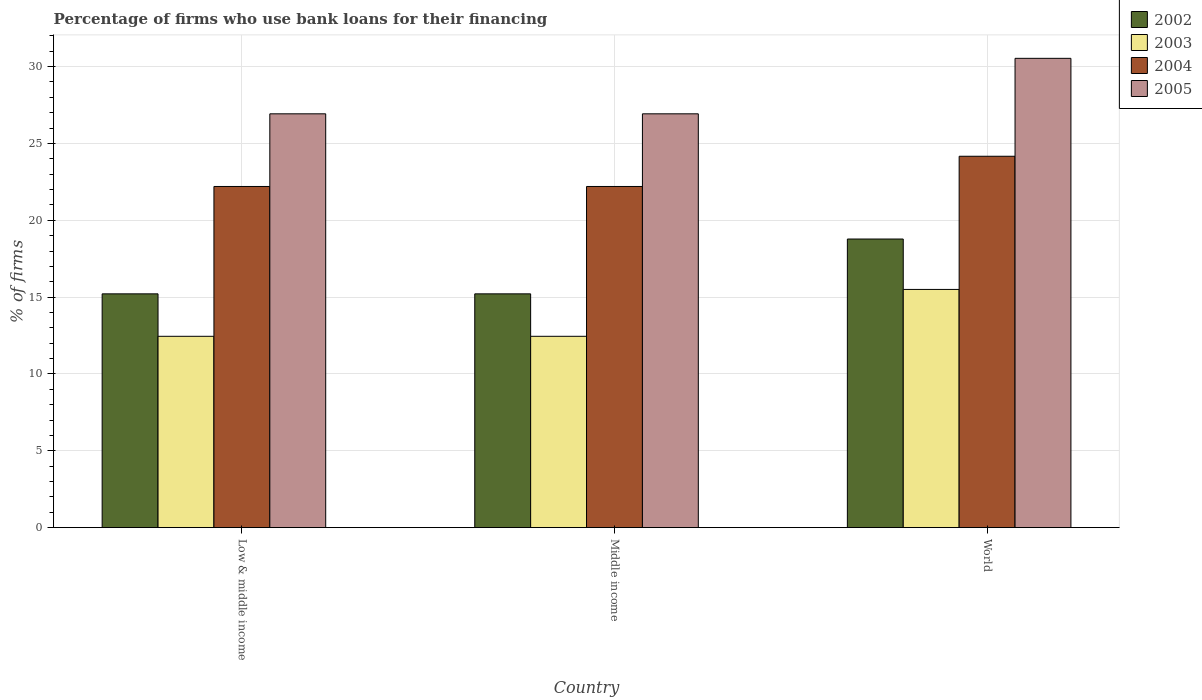How many different coloured bars are there?
Your response must be concise. 4. How many bars are there on the 3rd tick from the left?
Provide a short and direct response. 4. How many bars are there on the 1st tick from the right?
Your answer should be compact. 4. What is the label of the 3rd group of bars from the left?
Make the answer very short. World. In how many cases, is the number of bars for a given country not equal to the number of legend labels?
Ensure brevity in your answer.  0. What is the percentage of firms who use bank loans for their financing in 2003 in World?
Your answer should be compact. 15.5. Across all countries, what is the maximum percentage of firms who use bank loans for their financing in 2002?
Ensure brevity in your answer.  18.78. Across all countries, what is the minimum percentage of firms who use bank loans for their financing in 2004?
Keep it short and to the point. 22.2. What is the total percentage of firms who use bank loans for their financing in 2003 in the graph?
Give a very brief answer. 40.4. What is the difference between the percentage of firms who use bank loans for their financing in 2002 in Middle income and that in World?
Offer a terse response. -3.57. What is the difference between the percentage of firms who use bank loans for their financing in 2005 in Low & middle income and the percentage of firms who use bank loans for their financing in 2003 in Middle income?
Your response must be concise. 14.48. What is the average percentage of firms who use bank loans for their financing in 2003 per country?
Your answer should be compact. 13.47. What is the difference between the percentage of firms who use bank loans for their financing of/in 2003 and percentage of firms who use bank loans for their financing of/in 2004 in World?
Make the answer very short. -8.67. What is the ratio of the percentage of firms who use bank loans for their financing in 2004 in Middle income to that in World?
Ensure brevity in your answer.  0.92. What is the difference between the highest and the second highest percentage of firms who use bank loans for their financing in 2005?
Make the answer very short. -3.61. What is the difference between the highest and the lowest percentage of firms who use bank loans for their financing in 2004?
Provide a succinct answer. 1.97. In how many countries, is the percentage of firms who use bank loans for their financing in 2003 greater than the average percentage of firms who use bank loans for their financing in 2003 taken over all countries?
Offer a terse response. 1. Is the sum of the percentage of firms who use bank loans for their financing in 2002 in Low & middle income and World greater than the maximum percentage of firms who use bank loans for their financing in 2005 across all countries?
Your response must be concise. Yes. Is it the case that in every country, the sum of the percentage of firms who use bank loans for their financing in 2004 and percentage of firms who use bank loans for their financing in 2003 is greater than the sum of percentage of firms who use bank loans for their financing in 2002 and percentage of firms who use bank loans for their financing in 2005?
Your answer should be compact. No. Are all the bars in the graph horizontal?
Your answer should be very brief. No. How many countries are there in the graph?
Ensure brevity in your answer.  3. Are the values on the major ticks of Y-axis written in scientific E-notation?
Offer a terse response. No. Does the graph contain any zero values?
Offer a very short reply. No. Does the graph contain grids?
Provide a short and direct response. Yes. Where does the legend appear in the graph?
Your answer should be compact. Top right. What is the title of the graph?
Provide a short and direct response. Percentage of firms who use bank loans for their financing. What is the label or title of the Y-axis?
Make the answer very short. % of firms. What is the % of firms in 2002 in Low & middle income?
Offer a terse response. 15.21. What is the % of firms of 2003 in Low & middle income?
Your answer should be compact. 12.45. What is the % of firms in 2004 in Low & middle income?
Provide a succinct answer. 22.2. What is the % of firms of 2005 in Low & middle income?
Your answer should be very brief. 26.93. What is the % of firms in 2002 in Middle income?
Ensure brevity in your answer.  15.21. What is the % of firms in 2003 in Middle income?
Provide a short and direct response. 12.45. What is the % of firms in 2005 in Middle income?
Your answer should be compact. 26.93. What is the % of firms of 2002 in World?
Provide a succinct answer. 18.78. What is the % of firms in 2003 in World?
Offer a very short reply. 15.5. What is the % of firms of 2004 in World?
Make the answer very short. 24.17. What is the % of firms in 2005 in World?
Ensure brevity in your answer.  30.54. Across all countries, what is the maximum % of firms in 2002?
Ensure brevity in your answer.  18.78. Across all countries, what is the maximum % of firms of 2004?
Your response must be concise. 24.17. Across all countries, what is the maximum % of firms in 2005?
Your answer should be very brief. 30.54. Across all countries, what is the minimum % of firms in 2002?
Make the answer very short. 15.21. Across all countries, what is the minimum % of firms in 2003?
Your response must be concise. 12.45. Across all countries, what is the minimum % of firms in 2005?
Provide a succinct answer. 26.93. What is the total % of firms of 2002 in the graph?
Provide a short and direct response. 49.21. What is the total % of firms in 2003 in the graph?
Offer a very short reply. 40.4. What is the total % of firms of 2004 in the graph?
Ensure brevity in your answer.  68.57. What is the total % of firms of 2005 in the graph?
Offer a very short reply. 84.39. What is the difference between the % of firms of 2002 in Low & middle income and that in Middle income?
Offer a terse response. 0. What is the difference between the % of firms in 2005 in Low & middle income and that in Middle income?
Make the answer very short. 0. What is the difference between the % of firms in 2002 in Low & middle income and that in World?
Your answer should be very brief. -3.57. What is the difference between the % of firms of 2003 in Low & middle income and that in World?
Your response must be concise. -3.05. What is the difference between the % of firms in 2004 in Low & middle income and that in World?
Keep it short and to the point. -1.97. What is the difference between the % of firms of 2005 in Low & middle income and that in World?
Your answer should be very brief. -3.61. What is the difference between the % of firms in 2002 in Middle income and that in World?
Ensure brevity in your answer.  -3.57. What is the difference between the % of firms in 2003 in Middle income and that in World?
Make the answer very short. -3.05. What is the difference between the % of firms in 2004 in Middle income and that in World?
Offer a very short reply. -1.97. What is the difference between the % of firms of 2005 in Middle income and that in World?
Provide a succinct answer. -3.61. What is the difference between the % of firms in 2002 in Low & middle income and the % of firms in 2003 in Middle income?
Your answer should be very brief. 2.76. What is the difference between the % of firms of 2002 in Low & middle income and the % of firms of 2004 in Middle income?
Offer a terse response. -6.99. What is the difference between the % of firms in 2002 in Low & middle income and the % of firms in 2005 in Middle income?
Your response must be concise. -11.72. What is the difference between the % of firms in 2003 in Low & middle income and the % of firms in 2004 in Middle income?
Give a very brief answer. -9.75. What is the difference between the % of firms of 2003 in Low & middle income and the % of firms of 2005 in Middle income?
Keep it short and to the point. -14.48. What is the difference between the % of firms of 2004 in Low & middle income and the % of firms of 2005 in Middle income?
Ensure brevity in your answer.  -4.73. What is the difference between the % of firms of 2002 in Low & middle income and the % of firms of 2003 in World?
Offer a very short reply. -0.29. What is the difference between the % of firms in 2002 in Low & middle income and the % of firms in 2004 in World?
Give a very brief answer. -8.95. What is the difference between the % of firms of 2002 in Low & middle income and the % of firms of 2005 in World?
Provide a short and direct response. -15.33. What is the difference between the % of firms in 2003 in Low & middle income and the % of firms in 2004 in World?
Offer a terse response. -11.72. What is the difference between the % of firms in 2003 in Low & middle income and the % of firms in 2005 in World?
Give a very brief answer. -18.09. What is the difference between the % of firms of 2004 in Low & middle income and the % of firms of 2005 in World?
Provide a succinct answer. -8.34. What is the difference between the % of firms of 2002 in Middle income and the % of firms of 2003 in World?
Offer a terse response. -0.29. What is the difference between the % of firms of 2002 in Middle income and the % of firms of 2004 in World?
Your response must be concise. -8.95. What is the difference between the % of firms of 2002 in Middle income and the % of firms of 2005 in World?
Provide a short and direct response. -15.33. What is the difference between the % of firms of 2003 in Middle income and the % of firms of 2004 in World?
Your answer should be compact. -11.72. What is the difference between the % of firms in 2003 in Middle income and the % of firms in 2005 in World?
Provide a succinct answer. -18.09. What is the difference between the % of firms of 2004 in Middle income and the % of firms of 2005 in World?
Ensure brevity in your answer.  -8.34. What is the average % of firms in 2002 per country?
Offer a terse response. 16.4. What is the average % of firms of 2003 per country?
Offer a very short reply. 13.47. What is the average % of firms in 2004 per country?
Your answer should be very brief. 22.86. What is the average % of firms in 2005 per country?
Offer a terse response. 28.13. What is the difference between the % of firms of 2002 and % of firms of 2003 in Low & middle income?
Provide a short and direct response. 2.76. What is the difference between the % of firms in 2002 and % of firms in 2004 in Low & middle income?
Offer a terse response. -6.99. What is the difference between the % of firms in 2002 and % of firms in 2005 in Low & middle income?
Give a very brief answer. -11.72. What is the difference between the % of firms in 2003 and % of firms in 2004 in Low & middle income?
Ensure brevity in your answer.  -9.75. What is the difference between the % of firms in 2003 and % of firms in 2005 in Low & middle income?
Your answer should be compact. -14.48. What is the difference between the % of firms in 2004 and % of firms in 2005 in Low & middle income?
Your response must be concise. -4.73. What is the difference between the % of firms in 2002 and % of firms in 2003 in Middle income?
Ensure brevity in your answer.  2.76. What is the difference between the % of firms in 2002 and % of firms in 2004 in Middle income?
Offer a terse response. -6.99. What is the difference between the % of firms in 2002 and % of firms in 2005 in Middle income?
Make the answer very short. -11.72. What is the difference between the % of firms in 2003 and % of firms in 2004 in Middle income?
Provide a short and direct response. -9.75. What is the difference between the % of firms of 2003 and % of firms of 2005 in Middle income?
Your answer should be compact. -14.48. What is the difference between the % of firms in 2004 and % of firms in 2005 in Middle income?
Provide a succinct answer. -4.73. What is the difference between the % of firms in 2002 and % of firms in 2003 in World?
Keep it short and to the point. 3.28. What is the difference between the % of firms in 2002 and % of firms in 2004 in World?
Your answer should be compact. -5.39. What is the difference between the % of firms in 2002 and % of firms in 2005 in World?
Provide a short and direct response. -11.76. What is the difference between the % of firms in 2003 and % of firms in 2004 in World?
Provide a succinct answer. -8.67. What is the difference between the % of firms in 2003 and % of firms in 2005 in World?
Your response must be concise. -15.04. What is the difference between the % of firms of 2004 and % of firms of 2005 in World?
Give a very brief answer. -6.37. What is the ratio of the % of firms in 2002 in Low & middle income to that in Middle income?
Offer a terse response. 1. What is the ratio of the % of firms of 2004 in Low & middle income to that in Middle income?
Make the answer very short. 1. What is the ratio of the % of firms in 2005 in Low & middle income to that in Middle income?
Provide a succinct answer. 1. What is the ratio of the % of firms in 2002 in Low & middle income to that in World?
Ensure brevity in your answer.  0.81. What is the ratio of the % of firms in 2003 in Low & middle income to that in World?
Give a very brief answer. 0.8. What is the ratio of the % of firms in 2004 in Low & middle income to that in World?
Your answer should be compact. 0.92. What is the ratio of the % of firms in 2005 in Low & middle income to that in World?
Ensure brevity in your answer.  0.88. What is the ratio of the % of firms in 2002 in Middle income to that in World?
Make the answer very short. 0.81. What is the ratio of the % of firms of 2003 in Middle income to that in World?
Ensure brevity in your answer.  0.8. What is the ratio of the % of firms of 2004 in Middle income to that in World?
Give a very brief answer. 0.92. What is the ratio of the % of firms of 2005 in Middle income to that in World?
Your answer should be very brief. 0.88. What is the difference between the highest and the second highest % of firms in 2002?
Keep it short and to the point. 3.57. What is the difference between the highest and the second highest % of firms in 2003?
Ensure brevity in your answer.  3.05. What is the difference between the highest and the second highest % of firms of 2004?
Provide a short and direct response. 1.97. What is the difference between the highest and the second highest % of firms of 2005?
Offer a very short reply. 3.61. What is the difference between the highest and the lowest % of firms in 2002?
Provide a succinct answer. 3.57. What is the difference between the highest and the lowest % of firms of 2003?
Give a very brief answer. 3.05. What is the difference between the highest and the lowest % of firms in 2004?
Keep it short and to the point. 1.97. What is the difference between the highest and the lowest % of firms in 2005?
Provide a short and direct response. 3.61. 